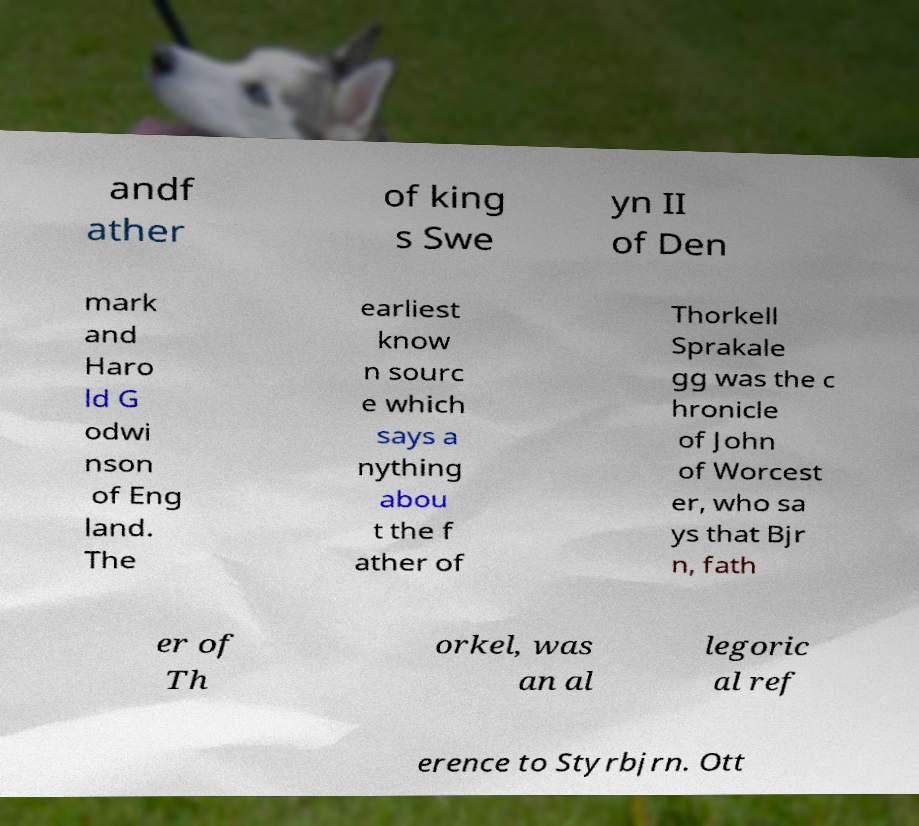Could you extract and type out the text from this image? andf ather of king s Swe yn II of Den mark and Haro ld G odwi nson of Eng land. The earliest know n sourc e which says a nything abou t the f ather of Thorkell Sprakale gg was the c hronicle of John of Worcest er, who sa ys that Bjr n, fath er of Th orkel, was an al legoric al ref erence to Styrbjrn. Ott 